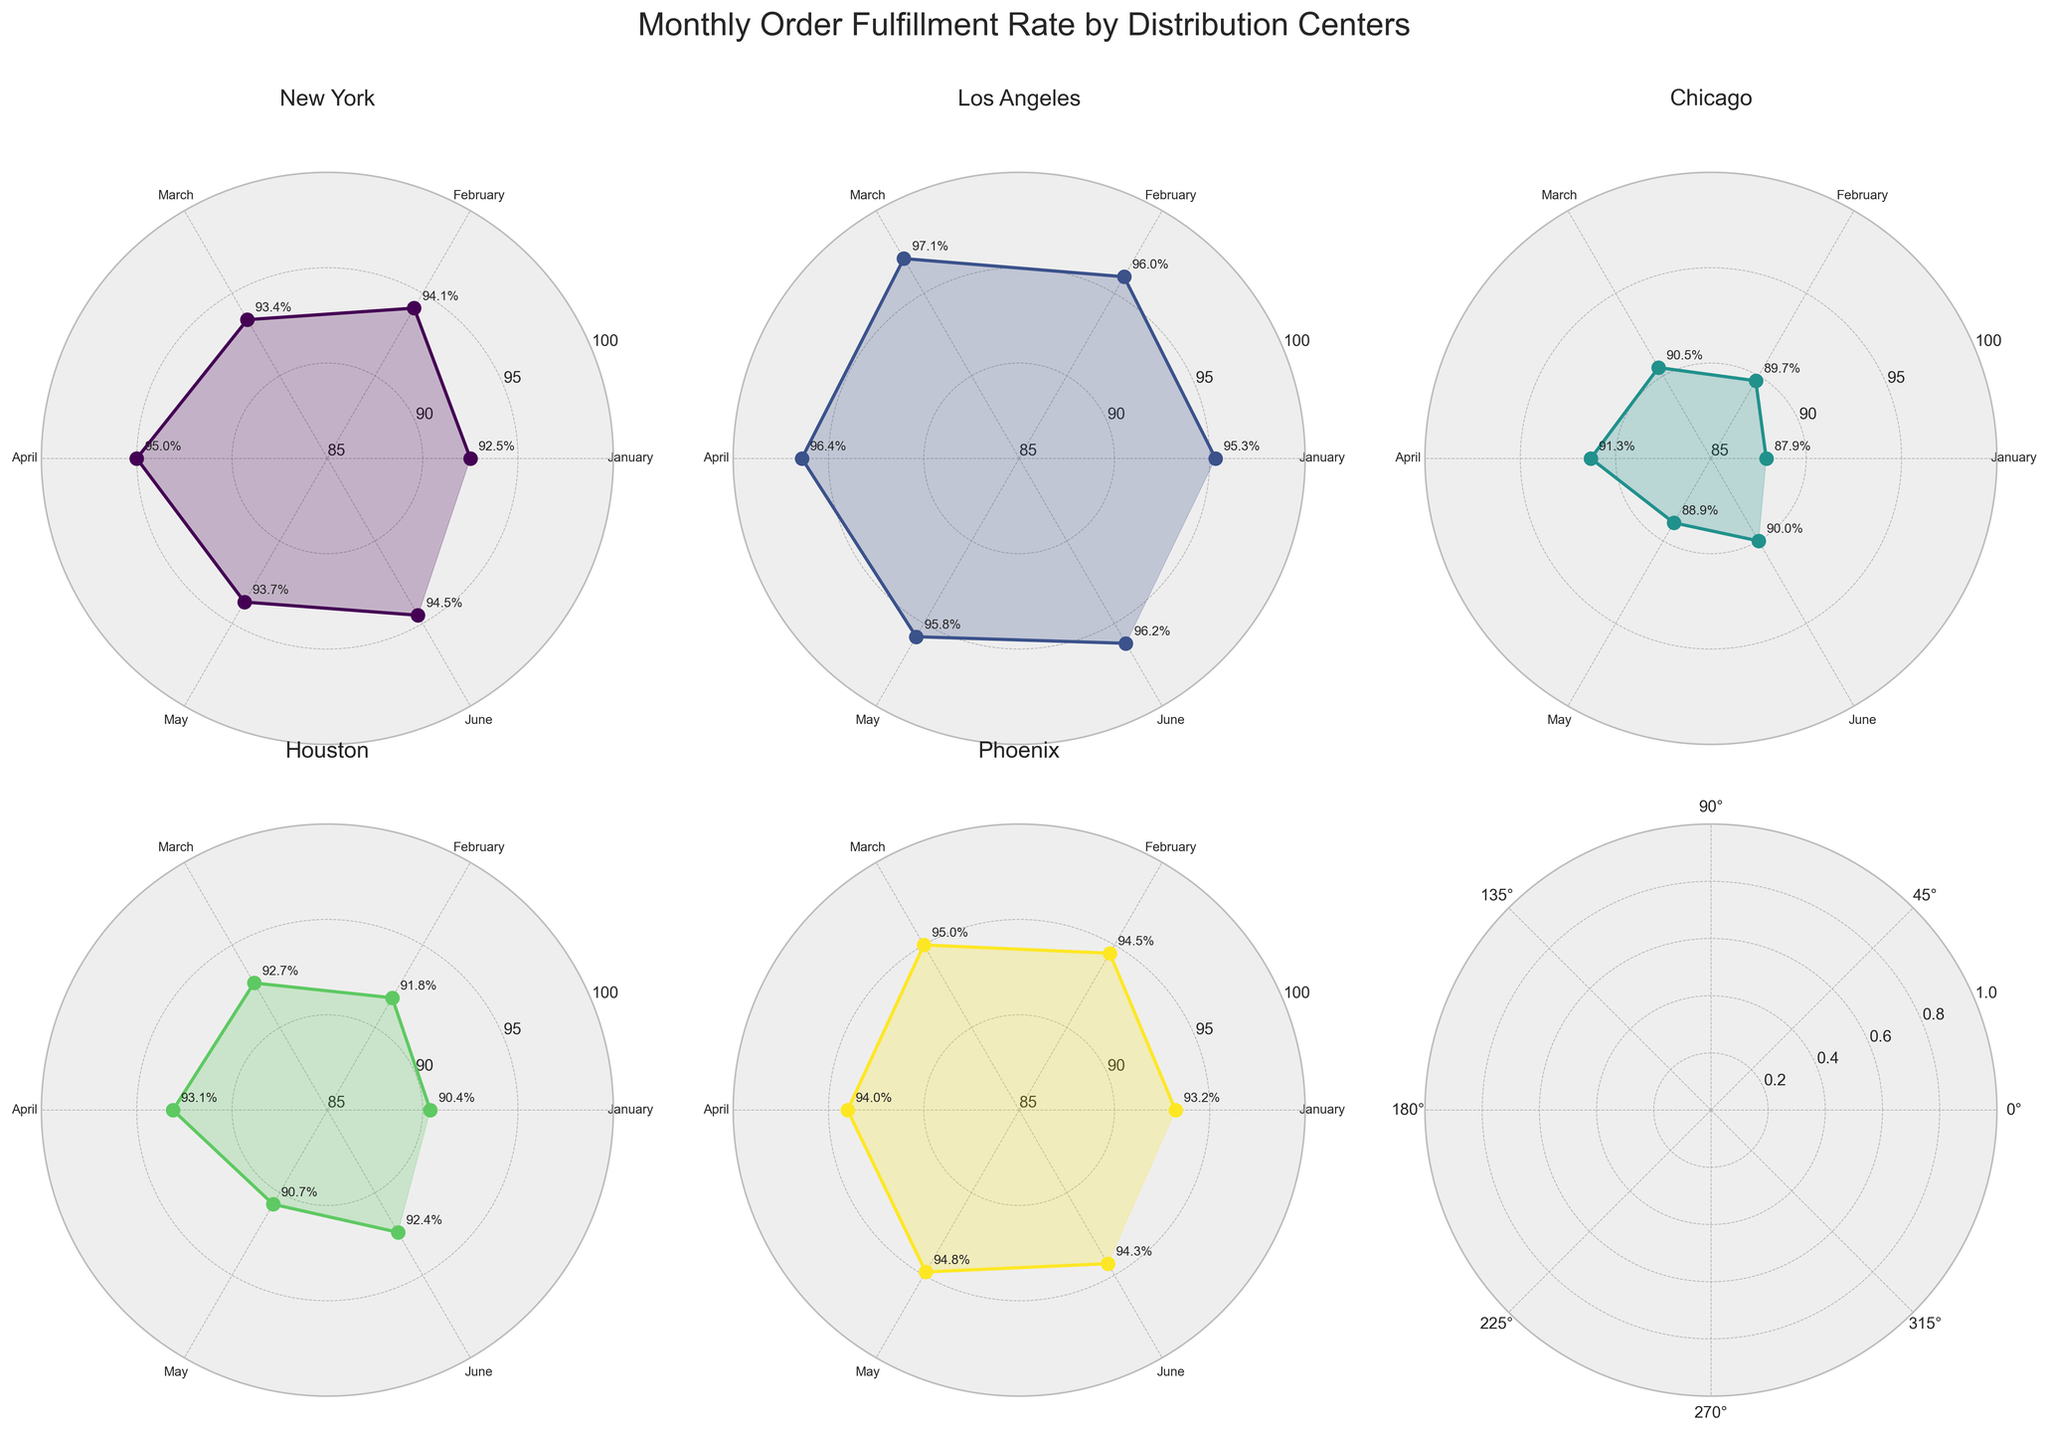What is the title of the figure? The title of the figure is written at the top and reads "Monthly Order Fulfillment Rate by Distribution Centers."
Answer: Monthly Order Fulfillment Rate by Distribution Centers Which month shows the highest order fulfillment rate for Los Angeles? By checking the polar chart subplot for Los Angeles, we can see from the labels that March has the highest rate with 97.1%.
Answer: March What is the average order fulfillment rate for New York across all months? To find the average, sum up the fulfillment rates for New York and divide by the number of months. The rates are 92.5, 94.1, 93.4, 95.0, 93.7, 94.5. Sum = 563.2, divide by 6 = 93.87
Answer: 93.87% Compare the order fulfillment rate of Chicago in January and Houston in March. Which is higher and by how much? In the subplots for Chicago and Houston, we compare January for Chicago (87.9%) and March for Houston (92.7%). Houston in March is higher. The difference is 92.7 - 87.9 = 4.8%.
Answer: Houston in March is higher by 4.8% Which location had the most significant improvement from January to June? To determine this, find the difference in rates for each location between January and June. 
- New York: 94.5 - 92.5 = 2.0
- Los Angeles: 96.2 - 95.3 = 0.9
- Chicago: 90.0 - 87.9 = 2.1
- Houston: 92.4 - 90.4 = 2.0
- Phoenix: 94.3 - 93.2 = 1.1
Chicago shows the most significant improvement.
Answer: Chicago with an improvement of 2.1% What is the overall trend of the order fulfillment rate for the Los Angeles location? By observing the polar chart for Los Angeles, we see that the rates gradually increase from January (95.3%) to March (97.1%), slightly decrease in April (96.4%), then stabilize around this level.
Answer: Generally increasing Which location has the most stable order fulfillment rate across all months? To determine stability, we need to observe the variance in rates. Phoenix shows the least fluctuation, with rates ranging closely around 94%-95% each month.
Answer: Phoenix Which month has the lowest order fulfillment rate for Chicago and what is the rate? Reviewing the chart for Chicago, January shows the lowest rate with 87.9%.
Answer: January with 87.9% Compare the highest order fulfillment rates among all locations in April. Which location has the highest rate? By checking each subplot for April, we see:
- New York: 95.0%
- Los Angeles: 96.4%
- Chicago: 91.3%
- Houston: 93.1%
- Phoenix: 94.0%
Los Angeles has the highest order fulfillment rate.
Answer: Los Angeles with 96.4% 